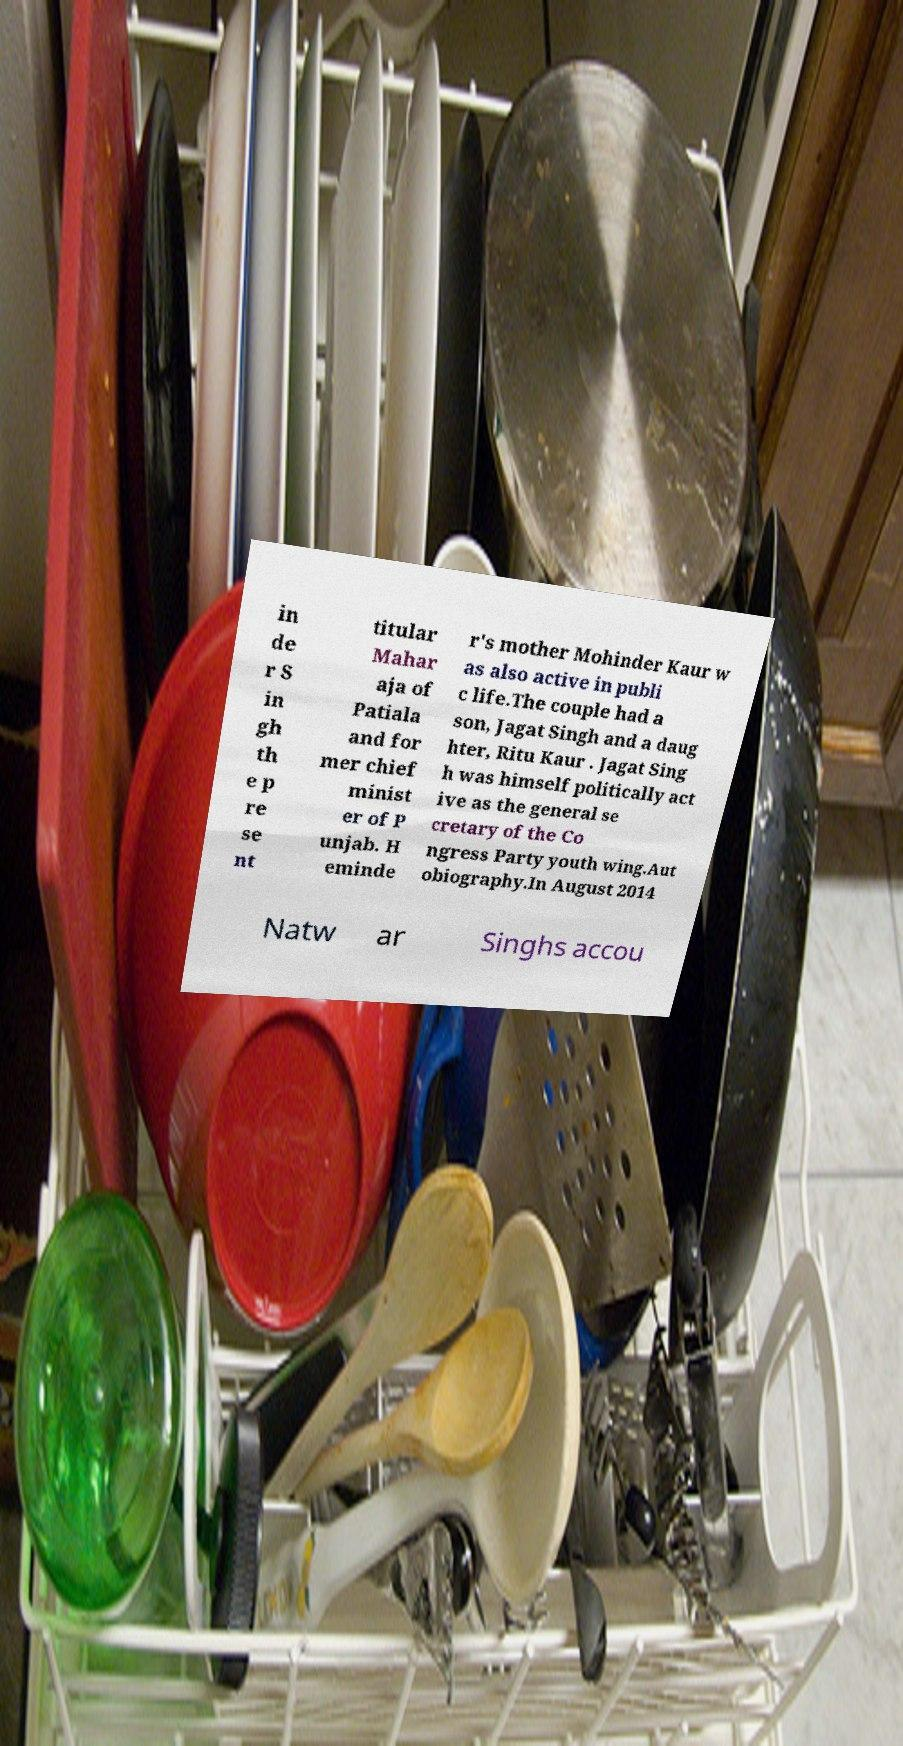There's text embedded in this image that I need extracted. Can you transcribe it verbatim? in de r S in gh th e p re se nt titular Mahar aja of Patiala and for mer chief minist er of P unjab. H eminde r's mother Mohinder Kaur w as also active in publi c life.The couple had a son, Jagat Singh and a daug hter, Ritu Kaur . Jagat Sing h was himself politically act ive as the general se cretary of the Co ngress Party youth wing.Aut obiography.In August 2014 Natw ar Singhs accou 